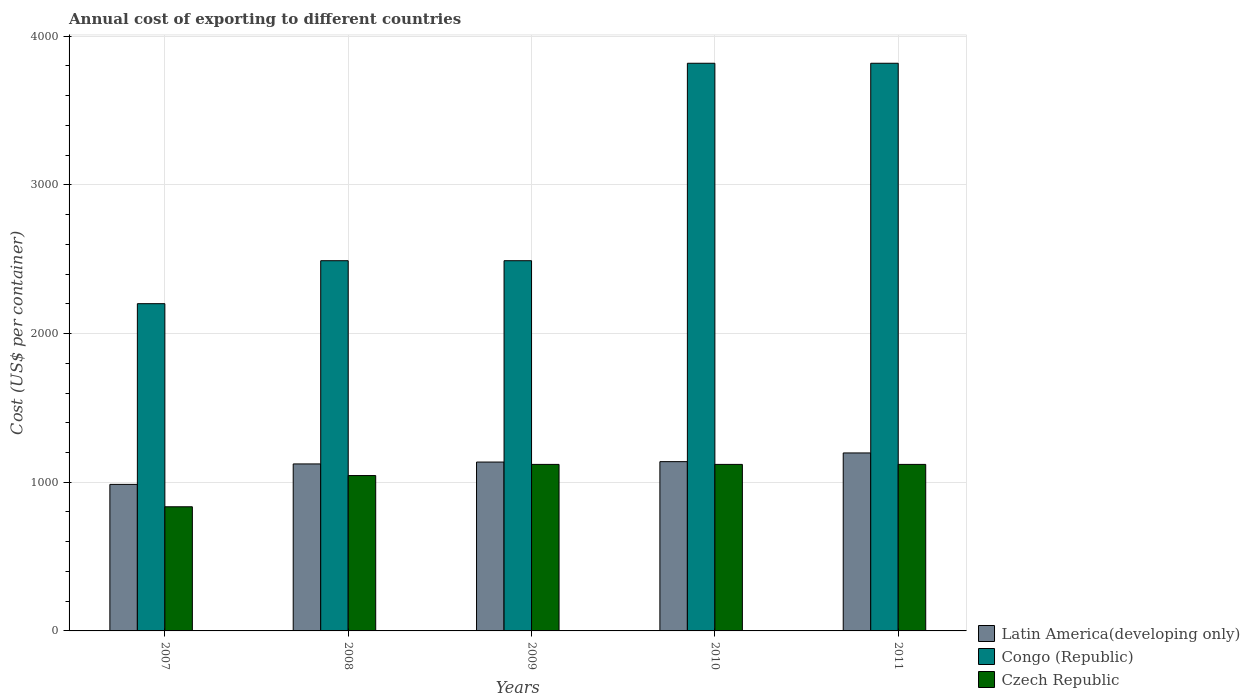How many different coloured bars are there?
Provide a succinct answer. 3. How many bars are there on the 1st tick from the left?
Your response must be concise. 3. How many bars are there on the 2nd tick from the right?
Ensure brevity in your answer.  3. What is the label of the 3rd group of bars from the left?
Keep it short and to the point. 2009. What is the total annual cost of exporting in Latin America(developing only) in 2008?
Your response must be concise. 1123.13. Across all years, what is the maximum total annual cost of exporting in Latin America(developing only)?
Make the answer very short. 1197.04. Across all years, what is the minimum total annual cost of exporting in Czech Republic?
Give a very brief answer. 835. What is the total total annual cost of exporting in Congo (Republic) in the graph?
Your response must be concise. 1.48e+04. What is the difference between the total annual cost of exporting in Congo (Republic) in 2007 and the total annual cost of exporting in Latin America(developing only) in 2010?
Make the answer very short. 1062.48. What is the average total annual cost of exporting in Congo (Republic) per year?
Offer a very short reply. 2963.4. In the year 2008, what is the difference between the total annual cost of exporting in Congo (Republic) and total annual cost of exporting in Czech Republic?
Offer a terse response. 1445. In how many years, is the total annual cost of exporting in Latin America(developing only) greater than 1400 US$?
Your response must be concise. 0. What is the ratio of the total annual cost of exporting in Latin America(developing only) in 2009 to that in 2011?
Offer a very short reply. 0.95. Is the difference between the total annual cost of exporting in Congo (Republic) in 2009 and 2011 greater than the difference between the total annual cost of exporting in Czech Republic in 2009 and 2011?
Make the answer very short. No. What is the difference between the highest and the second highest total annual cost of exporting in Congo (Republic)?
Offer a very short reply. 0. What is the difference between the highest and the lowest total annual cost of exporting in Latin America(developing only)?
Your answer should be compact. 211.43. In how many years, is the total annual cost of exporting in Congo (Republic) greater than the average total annual cost of exporting in Congo (Republic) taken over all years?
Your response must be concise. 2. Is the sum of the total annual cost of exporting in Czech Republic in 2010 and 2011 greater than the maximum total annual cost of exporting in Congo (Republic) across all years?
Your response must be concise. No. What does the 3rd bar from the left in 2011 represents?
Offer a very short reply. Czech Republic. What does the 3rd bar from the right in 2010 represents?
Ensure brevity in your answer.  Latin America(developing only). Is it the case that in every year, the sum of the total annual cost of exporting in Congo (Republic) and total annual cost of exporting in Latin America(developing only) is greater than the total annual cost of exporting in Czech Republic?
Your answer should be compact. Yes. How many bars are there?
Provide a short and direct response. 15. What is the difference between two consecutive major ticks on the Y-axis?
Provide a short and direct response. 1000. Are the values on the major ticks of Y-axis written in scientific E-notation?
Keep it short and to the point. No. Does the graph contain any zero values?
Ensure brevity in your answer.  No. How many legend labels are there?
Give a very brief answer. 3. How are the legend labels stacked?
Offer a terse response. Vertical. What is the title of the graph?
Make the answer very short. Annual cost of exporting to different countries. What is the label or title of the Y-axis?
Give a very brief answer. Cost (US$ per container). What is the Cost (US$ per container) in Latin America(developing only) in 2007?
Ensure brevity in your answer.  985.61. What is the Cost (US$ per container) in Congo (Republic) in 2007?
Provide a short and direct response. 2201. What is the Cost (US$ per container) in Czech Republic in 2007?
Keep it short and to the point. 835. What is the Cost (US$ per container) in Latin America(developing only) in 2008?
Ensure brevity in your answer.  1123.13. What is the Cost (US$ per container) in Congo (Republic) in 2008?
Keep it short and to the point. 2490. What is the Cost (US$ per container) of Czech Republic in 2008?
Provide a short and direct response. 1045. What is the Cost (US$ per container) of Latin America(developing only) in 2009?
Your answer should be very brief. 1135.74. What is the Cost (US$ per container) in Congo (Republic) in 2009?
Make the answer very short. 2490. What is the Cost (US$ per container) of Czech Republic in 2009?
Provide a short and direct response. 1120. What is the Cost (US$ per container) in Latin America(developing only) in 2010?
Keep it short and to the point. 1138.52. What is the Cost (US$ per container) of Congo (Republic) in 2010?
Your answer should be very brief. 3818. What is the Cost (US$ per container) in Czech Republic in 2010?
Offer a very short reply. 1120. What is the Cost (US$ per container) in Latin America(developing only) in 2011?
Provide a short and direct response. 1197.04. What is the Cost (US$ per container) in Congo (Republic) in 2011?
Offer a terse response. 3818. What is the Cost (US$ per container) of Czech Republic in 2011?
Keep it short and to the point. 1120. Across all years, what is the maximum Cost (US$ per container) of Latin America(developing only)?
Provide a succinct answer. 1197.04. Across all years, what is the maximum Cost (US$ per container) in Congo (Republic)?
Offer a very short reply. 3818. Across all years, what is the maximum Cost (US$ per container) of Czech Republic?
Your answer should be compact. 1120. Across all years, what is the minimum Cost (US$ per container) in Latin America(developing only)?
Provide a short and direct response. 985.61. Across all years, what is the minimum Cost (US$ per container) in Congo (Republic)?
Your answer should be very brief. 2201. Across all years, what is the minimum Cost (US$ per container) of Czech Republic?
Your answer should be compact. 835. What is the total Cost (US$ per container) of Latin America(developing only) in the graph?
Your response must be concise. 5580.04. What is the total Cost (US$ per container) of Congo (Republic) in the graph?
Your answer should be very brief. 1.48e+04. What is the total Cost (US$ per container) in Czech Republic in the graph?
Offer a terse response. 5240. What is the difference between the Cost (US$ per container) in Latin America(developing only) in 2007 and that in 2008?
Your answer should be compact. -137.52. What is the difference between the Cost (US$ per container) in Congo (Republic) in 2007 and that in 2008?
Keep it short and to the point. -289. What is the difference between the Cost (US$ per container) of Czech Republic in 2007 and that in 2008?
Provide a short and direct response. -210. What is the difference between the Cost (US$ per container) of Latin America(developing only) in 2007 and that in 2009?
Make the answer very short. -150.13. What is the difference between the Cost (US$ per container) of Congo (Republic) in 2007 and that in 2009?
Provide a succinct answer. -289. What is the difference between the Cost (US$ per container) in Czech Republic in 2007 and that in 2009?
Your answer should be compact. -285. What is the difference between the Cost (US$ per container) of Latin America(developing only) in 2007 and that in 2010?
Ensure brevity in your answer.  -152.91. What is the difference between the Cost (US$ per container) in Congo (Republic) in 2007 and that in 2010?
Offer a terse response. -1617. What is the difference between the Cost (US$ per container) of Czech Republic in 2007 and that in 2010?
Your response must be concise. -285. What is the difference between the Cost (US$ per container) of Latin America(developing only) in 2007 and that in 2011?
Offer a terse response. -211.43. What is the difference between the Cost (US$ per container) in Congo (Republic) in 2007 and that in 2011?
Make the answer very short. -1617. What is the difference between the Cost (US$ per container) of Czech Republic in 2007 and that in 2011?
Ensure brevity in your answer.  -285. What is the difference between the Cost (US$ per container) in Latin America(developing only) in 2008 and that in 2009?
Provide a succinct answer. -12.61. What is the difference between the Cost (US$ per container) in Congo (Republic) in 2008 and that in 2009?
Ensure brevity in your answer.  0. What is the difference between the Cost (US$ per container) of Czech Republic in 2008 and that in 2009?
Provide a short and direct response. -75. What is the difference between the Cost (US$ per container) in Latin America(developing only) in 2008 and that in 2010?
Your answer should be compact. -15.39. What is the difference between the Cost (US$ per container) of Congo (Republic) in 2008 and that in 2010?
Provide a short and direct response. -1328. What is the difference between the Cost (US$ per container) of Czech Republic in 2008 and that in 2010?
Your answer should be compact. -75. What is the difference between the Cost (US$ per container) of Latin America(developing only) in 2008 and that in 2011?
Provide a succinct answer. -73.91. What is the difference between the Cost (US$ per container) in Congo (Republic) in 2008 and that in 2011?
Give a very brief answer. -1328. What is the difference between the Cost (US$ per container) of Czech Republic in 2008 and that in 2011?
Your answer should be very brief. -75. What is the difference between the Cost (US$ per container) in Latin America(developing only) in 2009 and that in 2010?
Offer a terse response. -2.78. What is the difference between the Cost (US$ per container) of Congo (Republic) in 2009 and that in 2010?
Make the answer very short. -1328. What is the difference between the Cost (US$ per container) in Czech Republic in 2009 and that in 2010?
Offer a very short reply. 0. What is the difference between the Cost (US$ per container) of Latin America(developing only) in 2009 and that in 2011?
Provide a short and direct response. -61.3. What is the difference between the Cost (US$ per container) of Congo (Republic) in 2009 and that in 2011?
Offer a very short reply. -1328. What is the difference between the Cost (US$ per container) in Latin America(developing only) in 2010 and that in 2011?
Offer a very short reply. -58.52. What is the difference between the Cost (US$ per container) of Latin America(developing only) in 2007 and the Cost (US$ per container) of Congo (Republic) in 2008?
Your answer should be compact. -1504.39. What is the difference between the Cost (US$ per container) in Latin America(developing only) in 2007 and the Cost (US$ per container) in Czech Republic in 2008?
Provide a short and direct response. -59.39. What is the difference between the Cost (US$ per container) in Congo (Republic) in 2007 and the Cost (US$ per container) in Czech Republic in 2008?
Make the answer very short. 1156. What is the difference between the Cost (US$ per container) in Latin America(developing only) in 2007 and the Cost (US$ per container) in Congo (Republic) in 2009?
Provide a succinct answer. -1504.39. What is the difference between the Cost (US$ per container) in Latin America(developing only) in 2007 and the Cost (US$ per container) in Czech Republic in 2009?
Provide a short and direct response. -134.39. What is the difference between the Cost (US$ per container) in Congo (Republic) in 2007 and the Cost (US$ per container) in Czech Republic in 2009?
Give a very brief answer. 1081. What is the difference between the Cost (US$ per container) in Latin America(developing only) in 2007 and the Cost (US$ per container) in Congo (Republic) in 2010?
Make the answer very short. -2832.39. What is the difference between the Cost (US$ per container) in Latin America(developing only) in 2007 and the Cost (US$ per container) in Czech Republic in 2010?
Your answer should be very brief. -134.39. What is the difference between the Cost (US$ per container) of Congo (Republic) in 2007 and the Cost (US$ per container) of Czech Republic in 2010?
Provide a short and direct response. 1081. What is the difference between the Cost (US$ per container) of Latin America(developing only) in 2007 and the Cost (US$ per container) of Congo (Republic) in 2011?
Make the answer very short. -2832.39. What is the difference between the Cost (US$ per container) of Latin America(developing only) in 2007 and the Cost (US$ per container) of Czech Republic in 2011?
Make the answer very short. -134.39. What is the difference between the Cost (US$ per container) in Congo (Republic) in 2007 and the Cost (US$ per container) in Czech Republic in 2011?
Your answer should be compact. 1081. What is the difference between the Cost (US$ per container) in Latin America(developing only) in 2008 and the Cost (US$ per container) in Congo (Republic) in 2009?
Keep it short and to the point. -1366.87. What is the difference between the Cost (US$ per container) in Latin America(developing only) in 2008 and the Cost (US$ per container) in Czech Republic in 2009?
Offer a terse response. 3.13. What is the difference between the Cost (US$ per container) in Congo (Republic) in 2008 and the Cost (US$ per container) in Czech Republic in 2009?
Make the answer very short. 1370. What is the difference between the Cost (US$ per container) of Latin America(developing only) in 2008 and the Cost (US$ per container) of Congo (Republic) in 2010?
Offer a very short reply. -2694.87. What is the difference between the Cost (US$ per container) in Latin America(developing only) in 2008 and the Cost (US$ per container) in Czech Republic in 2010?
Provide a short and direct response. 3.13. What is the difference between the Cost (US$ per container) of Congo (Republic) in 2008 and the Cost (US$ per container) of Czech Republic in 2010?
Your answer should be compact. 1370. What is the difference between the Cost (US$ per container) of Latin America(developing only) in 2008 and the Cost (US$ per container) of Congo (Republic) in 2011?
Make the answer very short. -2694.87. What is the difference between the Cost (US$ per container) of Latin America(developing only) in 2008 and the Cost (US$ per container) of Czech Republic in 2011?
Provide a succinct answer. 3.13. What is the difference between the Cost (US$ per container) in Congo (Republic) in 2008 and the Cost (US$ per container) in Czech Republic in 2011?
Offer a terse response. 1370. What is the difference between the Cost (US$ per container) of Latin America(developing only) in 2009 and the Cost (US$ per container) of Congo (Republic) in 2010?
Ensure brevity in your answer.  -2682.26. What is the difference between the Cost (US$ per container) in Latin America(developing only) in 2009 and the Cost (US$ per container) in Czech Republic in 2010?
Make the answer very short. 15.74. What is the difference between the Cost (US$ per container) of Congo (Republic) in 2009 and the Cost (US$ per container) of Czech Republic in 2010?
Keep it short and to the point. 1370. What is the difference between the Cost (US$ per container) in Latin America(developing only) in 2009 and the Cost (US$ per container) in Congo (Republic) in 2011?
Ensure brevity in your answer.  -2682.26. What is the difference between the Cost (US$ per container) in Latin America(developing only) in 2009 and the Cost (US$ per container) in Czech Republic in 2011?
Keep it short and to the point. 15.74. What is the difference between the Cost (US$ per container) in Congo (Republic) in 2009 and the Cost (US$ per container) in Czech Republic in 2011?
Provide a short and direct response. 1370. What is the difference between the Cost (US$ per container) in Latin America(developing only) in 2010 and the Cost (US$ per container) in Congo (Republic) in 2011?
Give a very brief answer. -2679.48. What is the difference between the Cost (US$ per container) of Latin America(developing only) in 2010 and the Cost (US$ per container) of Czech Republic in 2011?
Provide a short and direct response. 18.52. What is the difference between the Cost (US$ per container) of Congo (Republic) in 2010 and the Cost (US$ per container) of Czech Republic in 2011?
Ensure brevity in your answer.  2698. What is the average Cost (US$ per container) of Latin America(developing only) per year?
Ensure brevity in your answer.  1116.01. What is the average Cost (US$ per container) of Congo (Republic) per year?
Provide a short and direct response. 2963.4. What is the average Cost (US$ per container) in Czech Republic per year?
Make the answer very short. 1048. In the year 2007, what is the difference between the Cost (US$ per container) in Latin America(developing only) and Cost (US$ per container) in Congo (Republic)?
Offer a very short reply. -1215.39. In the year 2007, what is the difference between the Cost (US$ per container) in Latin America(developing only) and Cost (US$ per container) in Czech Republic?
Provide a short and direct response. 150.61. In the year 2007, what is the difference between the Cost (US$ per container) of Congo (Republic) and Cost (US$ per container) of Czech Republic?
Provide a succinct answer. 1366. In the year 2008, what is the difference between the Cost (US$ per container) in Latin America(developing only) and Cost (US$ per container) in Congo (Republic)?
Provide a succinct answer. -1366.87. In the year 2008, what is the difference between the Cost (US$ per container) of Latin America(developing only) and Cost (US$ per container) of Czech Republic?
Offer a very short reply. 78.13. In the year 2008, what is the difference between the Cost (US$ per container) of Congo (Republic) and Cost (US$ per container) of Czech Republic?
Your answer should be compact. 1445. In the year 2009, what is the difference between the Cost (US$ per container) of Latin America(developing only) and Cost (US$ per container) of Congo (Republic)?
Keep it short and to the point. -1354.26. In the year 2009, what is the difference between the Cost (US$ per container) of Latin America(developing only) and Cost (US$ per container) of Czech Republic?
Keep it short and to the point. 15.74. In the year 2009, what is the difference between the Cost (US$ per container) in Congo (Republic) and Cost (US$ per container) in Czech Republic?
Your response must be concise. 1370. In the year 2010, what is the difference between the Cost (US$ per container) of Latin America(developing only) and Cost (US$ per container) of Congo (Republic)?
Provide a short and direct response. -2679.48. In the year 2010, what is the difference between the Cost (US$ per container) of Latin America(developing only) and Cost (US$ per container) of Czech Republic?
Ensure brevity in your answer.  18.52. In the year 2010, what is the difference between the Cost (US$ per container) in Congo (Republic) and Cost (US$ per container) in Czech Republic?
Your response must be concise. 2698. In the year 2011, what is the difference between the Cost (US$ per container) in Latin America(developing only) and Cost (US$ per container) in Congo (Republic)?
Your response must be concise. -2620.96. In the year 2011, what is the difference between the Cost (US$ per container) in Latin America(developing only) and Cost (US$ per container) in Czech Republic?
Your response must be concise. 77.04. In the year 2011, what is the difference between the Cost (US$ per container) of Congo (Republic) and Cost (US$ per container) of Czech Republic?
Provide a short and direct response. 2698. What is the ratio of the Cost (US$ per container) of Latin America(developing only) in 2007 to that in 2008?
Your answer should be compact. 0.88. What is the ratio of the Cost (US$ per container) in Congo (Republic) in 2007 to that in 2008?
Keep it short and to the point. 0.88. What is the ratio of the Cost (US$ per container) in Czech Republic in 2007 to that in 2008?
Your answer should be very brief. 0.8. What is the ratio of the Cost (US$ per container) in Latin America(developing only) in 2007 to that in 2009?
Offer a very short reply. 0.87. What is the ratio of the Cost (US$ per container) in Congo (Republic) in 2007 to that in 2009?
Ensure brevity in your answer.  0.88. What is the ratio of the Cost (US$ per container) in Czech Republic in 2007 to that in 2009?
Make the answer very short. 0.75. What is the ratio of the Cost (US$ per container) in Latin America(developing only) in 2007 to that in 2010?
Keep it short and to the point. 0.87. What is the ratio of the Cost (US$ per container) of Congo (Republic) in 2007 to that in 2010?
Your answer should be very brief. 0.58. What is the ratio of the Cost (US$ per container) of Czech Republic in 2007 to that in 2010?
Provide a succinct answer. 0.75. What is the ratio of the Cost (US$ per container) in Latin America(developing only) in 2007 to that in 2011?
Your answer should be very brief. 0.82. What is the ratio of the Cost (US$ per container) in Congo (Republic) in 2007 to that in 2011?
Your answer should be very brief. 0.58. What is the ratio of the Cost (US$ per container) of Czech Republic in 2007 to that in 2011?
Give a very brief answer. 0.75. What is the ratio of the Cost (US$ per container) in Latin America(developing only) in 2008 to that in 2009?
Your response must be concise. 0.99. What is the ratio of the Cost (US$ per container) of Congo (Republic) in 2008 to that in 2009?
Keep it short and to the point. 1. What is the ratio of the Cost (US$ per container) of Czech Republic in 2008 to that in 2009?
Make the answer very short. 0.93. What is the ratio of the Cost (US$ per container) in Latin America(developing only) in 2008 to that in 2010?
Your answer should be compact. 0.99. What is the ratio of the Cost (US$ per container) of Congo (Republic) in 2008 to that in 2010?
Your answer should be compact. 0.65. What is the ratio of the Cost (US$ per container) of Czech Republic in 2008 to that in 2010?
Keep it short and to the point. 0.93. What is the ratio of the Cost (US$ per container) of Latin America(developing only) in 2008 to that in 2011?
Your answer should be compact. 0.94. What is the ratio of the Cost (US$ per container) in Congo (Republic) in 2008 to that in 2011?
Give a very brief answer. 0.65. What is the ratio of the Cost (US$ per container) of Czech Republic in 2008 to that in 2011?
Your answer should be very brief. 0.93. What is the ratio of the Cost (US$ per container) in Latin America(developing only) in 2009 to that in 2010?
Your answer should be very brief. 1. What is the ratio of the Cost (US$ per container) of Congo (Republic) in 2009 to that in 2010?
Your response must be concise. 0.65. What is the ratio of the Cost (US$ per container) of Czech Republic in 2009 to that in 2010?
Provide a succinct answer. 1. What is the ratio of the Cost (US$ per container) in Latin America(developing only) in 2009 to that in 2011?
Provide a succinct answer. 0.95. What is the ratio of the Cost (US$ per container) in Congo (Republic) in 2009 to that in 2011?
Provide a succinct answer. 0.65. What is the ratio of the Cost (US$ per container) in Czech Republic in 2009 to that in 2011?
Ensure brevity in your answer.  1. What is the ratio of the Cost (US$ per container) of Latin America(developing only) in 2010 to that in 2011?
Make the answer very short. 0.95. What is the ratio of the Cost (US$ per container) in Congo (Republic) in 2010 to that in 2011?
Keep it short and to the point. 1. What is the ratio of the Cost (US$ per container) in Czech Republic in 2010 to that in 2011?
Keep it short and to the point. 1. What is the difference between the highest and the second highest Cost (US$ per container) in Latin America(developing only)?
Offer a terse response. 58.52. What is the difference between the highest and the second highest Cost (US$ per container) of Congo (Republic)?
Ensure brevity in your answer.  0. What is the difference between the highest and the second highest Cost (US$ per container) of Czech Republic?
Keep it short and to the point. 0. What is the difference between the highest and the lowest Cost (US$ per container) in Latin America(developing only)?
Provide a short and direct response. 211.43. What is the difference between the highest and the lowest Cost (US$ per container) in Congo (Republic)?
Your answer should be compact. 1617. What is the difference between the highest and the lowest Cost (US$ per container) in Czech Republic?
Make the answer very short. 285. 